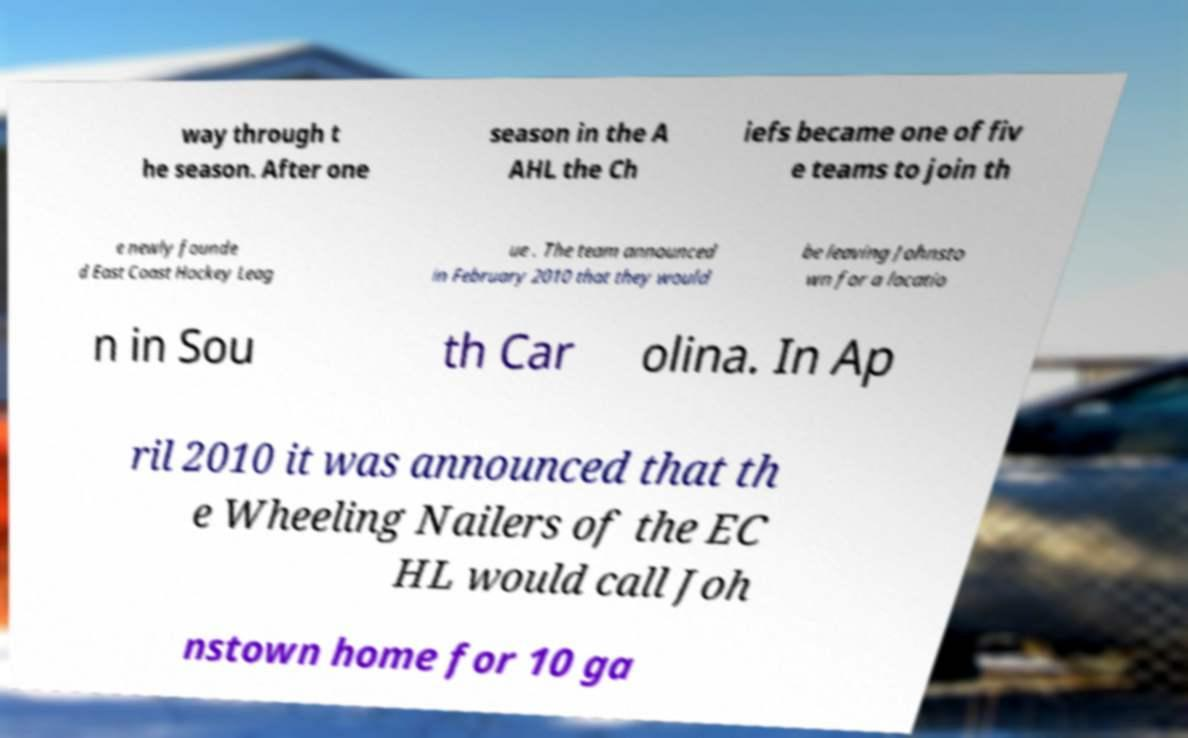Please identify and transcribe the text found in this image. way through t he season. After one season in the A AHL the Ch iefs became one of fiv e teams to join th e newly founde d East Coast Hockey Leag ue . The team announced in February 2010 that they would be leaving Johnsto wn for a locatio n in Sou th Car olina. In Ap ril 2010 it was announced that th e Wheeling Nailers of the EC HL would call Joh nstown home for 10 ga 